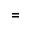<formula> <loc_0><loc_0><loc_500><loc_500>=</formula> 